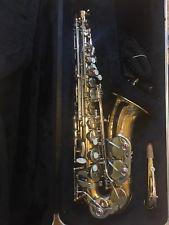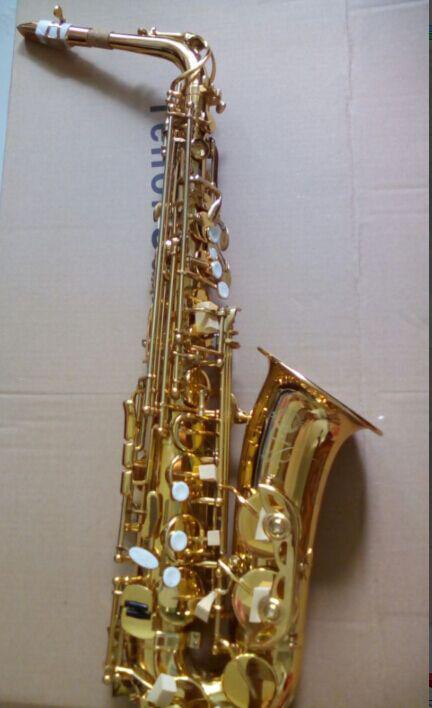The first image is the image on the left, the second image is the image on the right. Analyze the images presented: Is the assertion "At least one sax has water coming out of it." valid? Answer yes or no. No. The first image is the image on the left, the second image is the image on the right. Examine the images to the left and right. Is the description "In one or more if the images a musical instrument has been converted to function as a water fountain." accurate? Answer yes or no. No. 